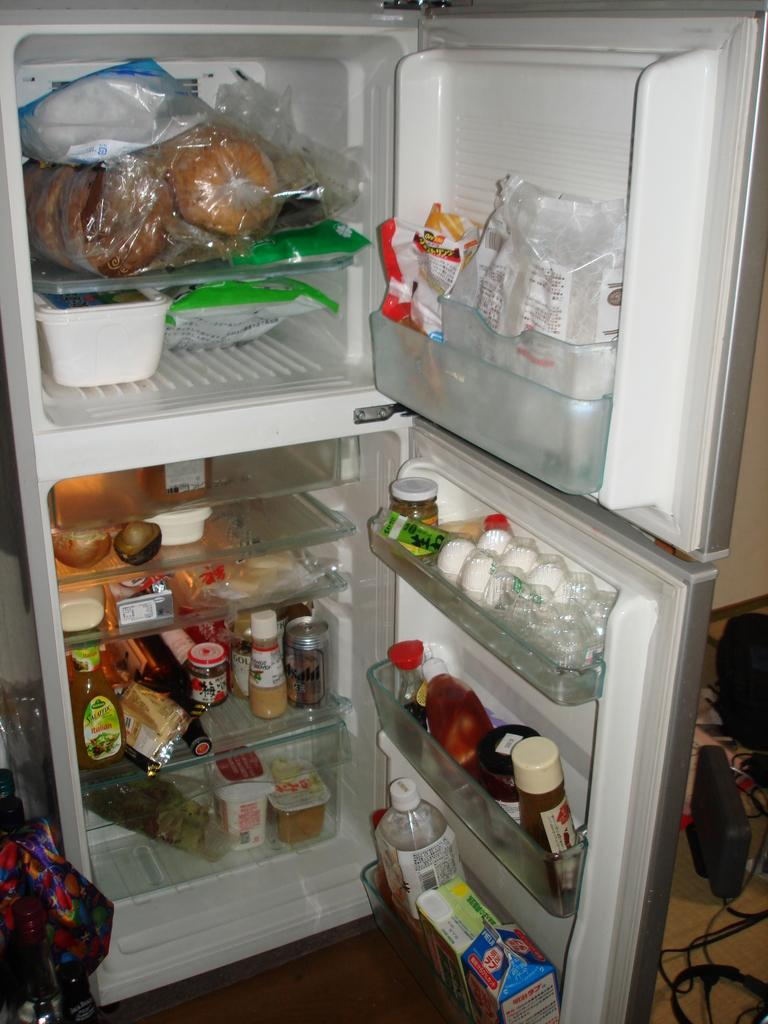What type of products can be seen in the image? There are grocery products in the image. Can you identify any specific items among the grocery products? Yes, there are bottles and eggs in the image. Are there any other items visible in the image? Yes, there are other items in the image. Where are all of these items located? All of these items are inside a refrigerator. What type of record can be seen in the image? There is no record present in the image. Is there a gun visible in the image? No, there is no gun visible in the image. 